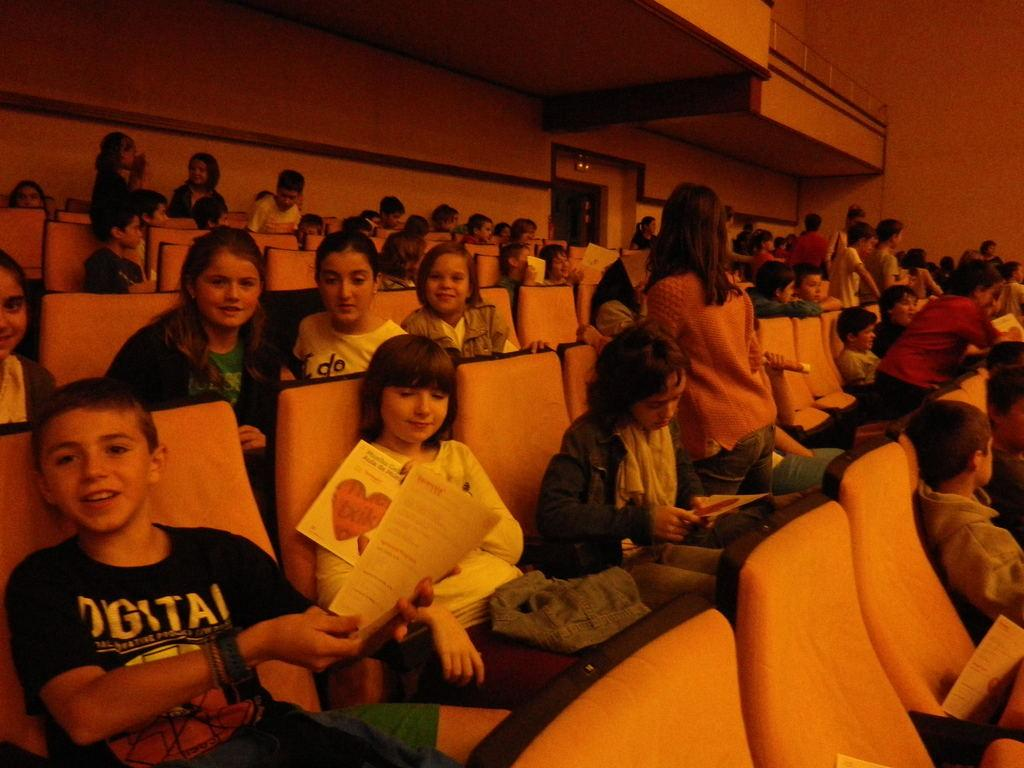What type of building is shown in the image? There is an auditorium in the image. How many people are present in the image? There are many people in the image. Can you describe the actions of some people in the image? There are a few people holding objects in their hands in the image. What type of animals can be seen at the zoo in the image? There is no zoo present in the image; it features an auditorium with many people. How does the steam affect the property in the image? There is no steam or property mentioned in the image; it only shows an auditorium and people. 